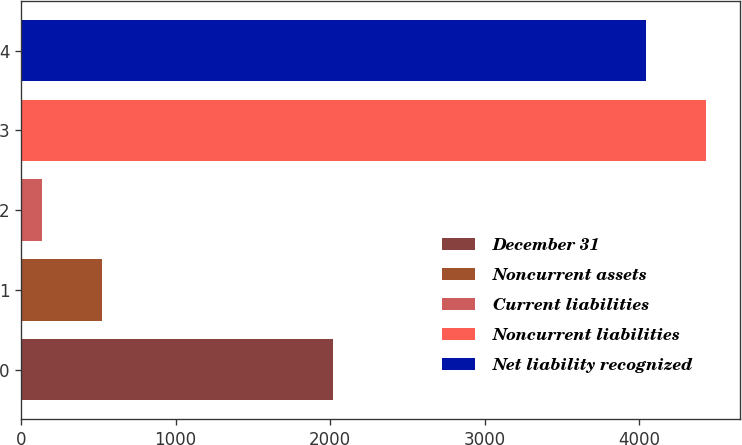Convert chart to OTSL. <chart><loc_0><loc_0><loc_500><loc_500><bar_chart><fcel>December 31<fcel>Noncurrent assets<fcel>Current liabilities<fcel>Noncurrent liabilities<fcel>Net liability recognized<nl><fcel>2016<fcel>523.6<fcel>132<fcel>4433.6<fcel>4042<nl></chart> 